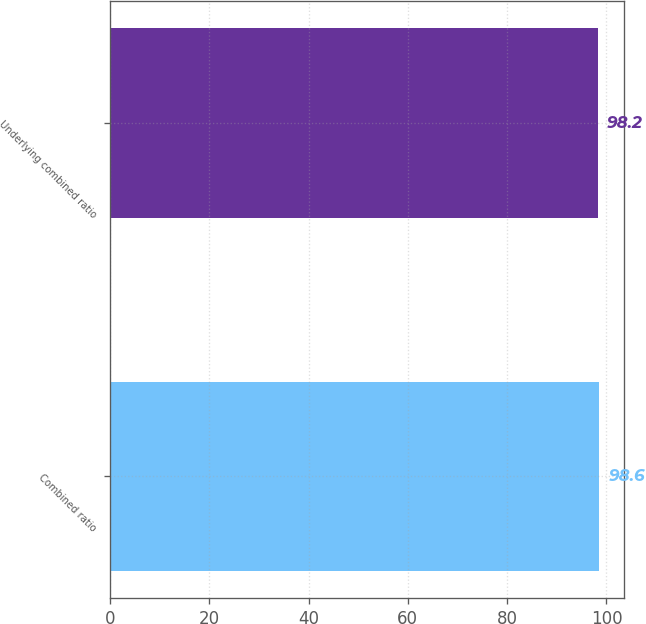Convert chart. <chart><loc_0><loc_0><loc_500><loc_500><bar_chart><fcel>Combined ratio<fcel>Underlying combined ratio<nl><fcel>98.6<fcel>98.2<nl></chart> 